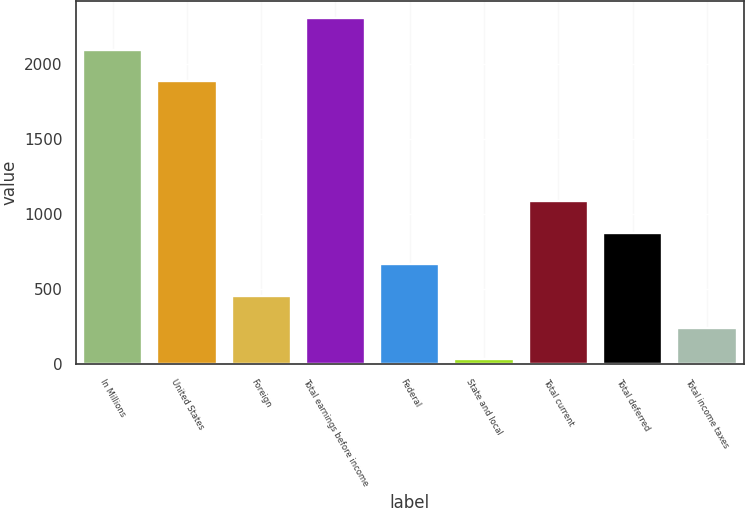Convert chart to OTSL. <chart><loc_0><loc_0><loc_500><loc_500><bar_chart><fcel>In Millions<fcel>United States<fcel>Foreign<fcel>Total earnings before income<fcel>Federal<fcel>State and local<fcel>Total current<fcel>Total deferred<fcel>Total income taxes<nl><fcel>2094.04<fcel>1884<fcel>455.28<fcel>2304.08<fcel>665.32<fcel>35.2<fcel>1085.4<fcel>875.36<fcel>245.24<nl></chart> 